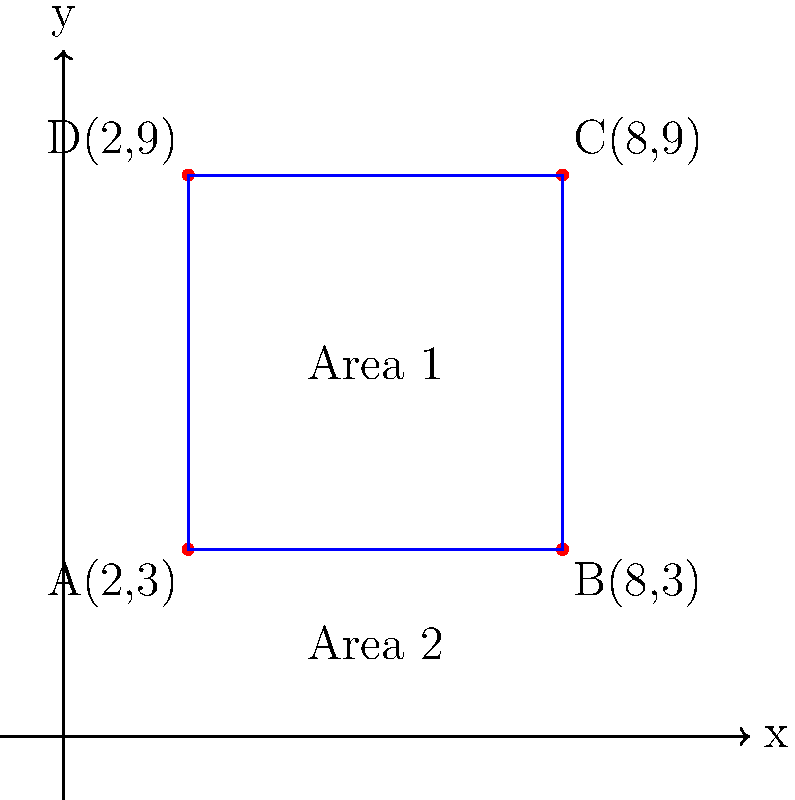A claims adjuster is investigating four property damage claims located at points A(2,3), B(8,3), C(8,9), and D(2,9) on a coordinate grid. These points form a rectangle. The claims manager wants to know the total area covered by these claims. What is the area of the rectangle formed by these four claim locations? Let's approach this step-by-step:

1. Identify the length and width of the rectangle:
   - Length: difference in x-coordinates of points A and B
     $l = 8 - 2 = 6$ units
   - Width: difference in y-coordinates of points A and D
     $w = 9 - 3 = 6$ units

2. Calculate the area of the rectangle using the formula:
   $A = l \times w$
   
   Where:
   $A$ = Area
   $l$ = Length
   $w$ = Width

3. Substitute the values:
   $A = 6 \times 6 = 36$ square units

Therefore, the area of the rectangle formed by the four claim locations is 36 square units.
Answer: 36 square units 